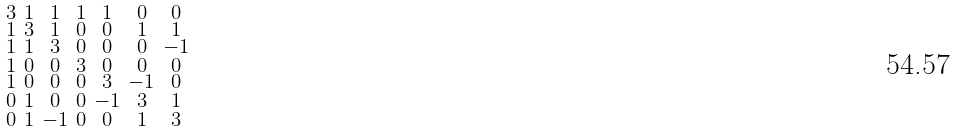Convert formula to latex. <formula><loc_0><loc_0><loc_500><loc_500>\begin{smallmatrix} 3 & 1 & 1 & 1 & 1 & 0 & 0 \\ 1 & 3 & 1 & 0 & 0 & 1 & 1 \\ 1 & 1 & 3 & 0 & 0 & 0 & - 1 \\ 1 & 0 & 0 & 3 & 0 & 0 & 0 \\ 1 & 0 & 0 & 0 & 3 & - 1 & 0 \\ 0 & 1 & 0 & 0 & - 1 & 3 & 1 \\ 0 & 1 & - 1 & 0 & 0 & 1 & 3 \end{smallmatrix}</formula> 